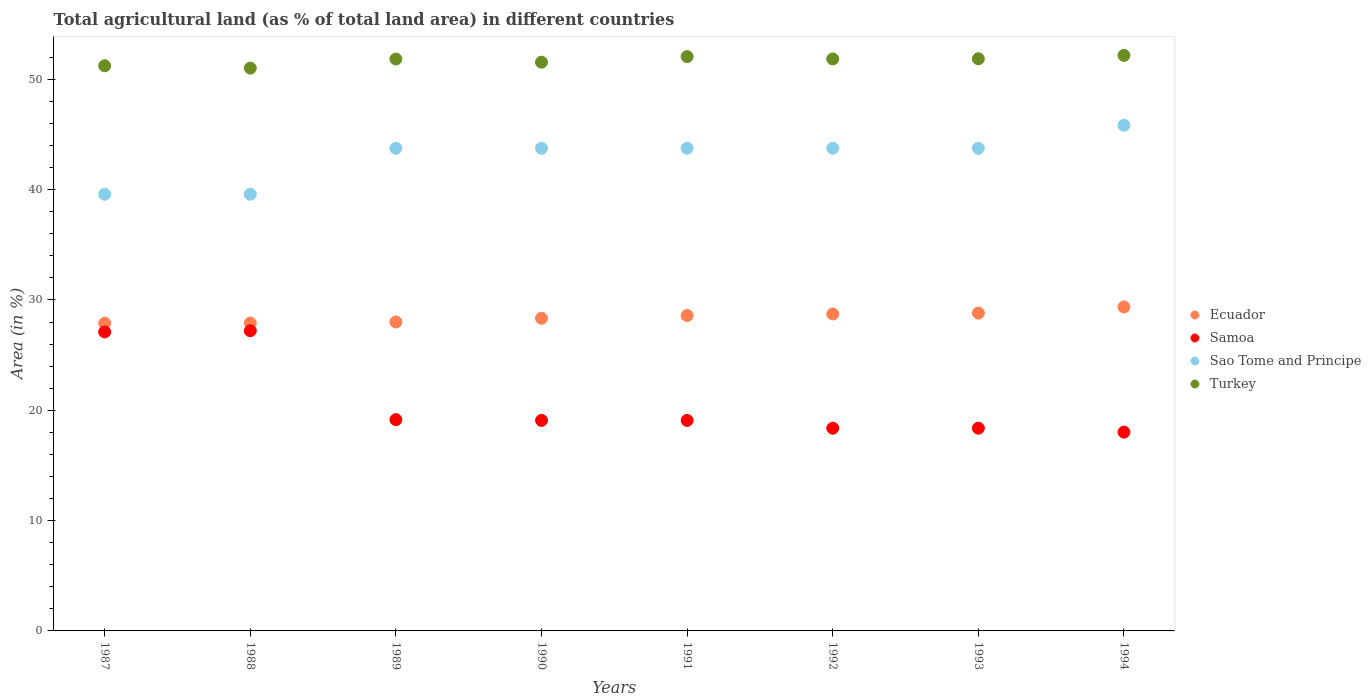Is the number of dotlines equal to the number of legend labels?
Keep it short and to the point. Yes. What is the percentage of agricultural land in Sao Tome and Principe in 1992?
Ensure brevity in your answer.  43.75. Across all years, what is the maximum percentage of agricultural land in Turkey?
Offer a terse response. 52.17. Across all years, what is the minimum percentage of agricultural land in Samoa?
Make the answer very short. 18.02. In which year was the percentage of agricultural land in Turkey minimum?
Your answer should be very brief. 1988. What is the total percentage of agricultural land in Sao Tome and Principe in the graph?
Your answer should be compact. 343.75. What is the difference between the percentage of agricultural land in Samoa in 1988 and that in 1994?
Provide a short and direct response. 9.19. What is the difference between the percentage of agricultural land in Samoa in 1993 and the percentage of agricultural land in Ecuador in 1992?
Provide a short and direct response. -10.35. What is the average percentage of agricultural land in Sao Tome and Principe per year?
Make the answer very short. 42.97. In the year 1990, what is the difference between the percentage of agricultural land in Samoa and percentage of agricultural land in Turkey?
Provide a succinct answer. -32.47. In how many years, is the percentage of agricultural land in Ecuador greater than 20 %?
Make the answer very short. 8. What is the ratio of the percentage of agricultural land in Ecuador in 1989 to that in 1991?
Give a very brief answer. 0.98. Is the percentage of agricultural land in Samoa in 1989 less than that in 1990?
Offer a very short reply. No. What is the difference between the highest and the second highest percentage of agricultural land in Samoa?
Ensure brevity in your answer.  0.11. What is the difference between the highest and the lowest percentage of agricultural land in Ecuador?
Make the answer very short. 1.47. In how many years, is the percentage of agricultural land in Ecuador greater than the average percentage of agricultural land in Ecuador taken over all years?
Your answer should be compact. 4. Is the sum of the percentage of agricultural land in Ecuador in 1989 and 1992 greater than the maximum percentage of agricultural land in Samoa across all years?
Your answer should be very brief. Yes. Is it the case that in every year, the sum of the percentage of agricultural land in Samoa and percentage of agricultural land in Turkey  is greater than the sum of percentage of agricultural land in Sao Tome and Principe and percentage of agricultural land in Ecuador?
Your response must be concise. No. Does the percentage of agricultural land in Samoa monotonically increase over the years?
Offer a very short reply. No. How many dotlines are there?
Provide a short and direct response. 4. Are the values on the major ticks of Y-axis written in scientific E-notation?
Provide a succinct answer. No. How many legend labels are there?
Your answer should be compact. 4. What is the title of the graph?
Provide a succinct answer. Total agricultural land (as % of total land area) in different countries. Does "Europe(all income levels)" appear as one of the legend labels in the graph?
Offer a terse response. No. What is the label or title of the Y-axis?
Offer a very short reply. Area (in %). What is the Area (in %) of Ecuador in 1987?
Give a very brief answer. 27.89. What is the Area (in %) in Samoa in 1987?
Your answer should be very brief. 27.1. What is the Area (in %) in Sao Tome and Principe in 1987?
Provide a short and direct response. 39.58. What is the Area (in %) in Turkey in 1987?
Your response must be concise. 51.23. What is the Area (in %) in Ecuador in 1988?
Make the answer very short. 27.91. What is the Area (in %) of Samoa in 1988?
Offer a terse response. 27.21. What is the Area (in %) of Sao Tome and Principe in 1988?
Keep it short and to the point. 39.58. What is the Area (in %) of Turkey in 1988?
Ensure brevity in your answer.  51.02. What is the Area (in %) in Ecuador in 1989?
Your answer should be very brief. 28.01. What is the Area (in %) in Samoa in 1989?
Give a very brief answer. 19.15. What is the Area (in %) of Sao Tome and Principe in 1989?
Offer a very short reply. 43.75. What is the Area (in %) of Turkey in 1989?
Give a very brief answer. 51.84. What is the Area (in %) in Ecuador in 1990?
Your answer should be very brief. 28.34. What is the Area (in %) of Samoa in 1990?
Give a very brief answer. 19.08. What is the Area (in %) in Sao Tome and Principe in 1990?
Provide a short and direct response. 43.75. What is the Area (in %) of Turkey in 1990?
Offer a very short reply. 51.55. What is the Area (in %) in Ecuador in 1991?
Offer a very short reply. 28.59. What is the Area (in %) of Samoa in 1991?
Offer a terse response. 19.08. What is the Area (in %) in Sao Tome and Principe in 1991?
Give a very brief answer. 43.75. What is the Area (in %) in Turkey in 1991?
Offer a very short reply. 52.06. What is the Area (in %) of Ecuador in 1992?
Provide a succinct answer. 28.73. What is the Area (in %) in Samoa in 1992?
Keep it short and to the point. 18.37. What is the Area (in %) of Sao Tome and Principe in 1992?
Offer a very short reply. 43.75. What is the Area (in %) of Turkey in 1992?
Give a very brief answer. 51.85. What is the Area (in %) of Ecuador in 1993?
Your answer should be compact. 28.81. What is the Area (in %) of Samoa in 1993?
Offer a very short reply. 18.37. What is the Area (in %) in Sao Tome and Principe in 1993?
Give a very brief answer. 43.75. What is the Area (in %) in Turkey in 1993?
Your answer should be very brief. 51.86. What is the Area (in %) in Ecuador in 1994?
Ensure brevity in your answer.  29.36. What is the Area (in %) in Samoa in 1994?
Your answer should be very brief. 18.02. What is the Area (in %) of Sao Tome and Principe in 1994?
Ensure brevity in your answer.  45.83. What is the Area (in %) of Turkey in 1994?
Offer a terse response. 52.17. Across all years, what is the maximum Area (in %) of Ecuador?
Give a very brief answer. 29.36. Across all years, what is the maximum Area (in %) of Samoa?
Your answer should be compact. 27.21. Across all years, what is the maximum Area (in %) of Sao Tome and Principe?
Offer a terse response. 45.83. Across all years, what is the maximum Area (in %) in Turkey?
Your response must be concise. 52.17. Across all years, what is the minimum Area (in %) of Ecuador?
Your answer should be very brief. 27.89. Across all years, what is the minimum Area (in %) in Samoa?
Make the answer very short. 18.02. Across all years, what is the minimum Area (in %) of Sao Tome and Principe?
Offer a terse response. 39.58. Across all years, what is the minimum Area (in %) of Turkey?
Offer a very short reply. 51.02. What is the total Area (in %) in Ecuador in the graph?
Make the answer very short. 227.63. What is the total Area (in %) in Samoa in the graph?
Give a very brief answer. 166.4. What is the total Area (in %) in Sao Tome and Principe in the graph?
Make the answer very short. 343.75. What is the total Area (in %) in Turkey in the graph?
Offer a terse response. 413.57. What is the difference between the Area (in %) in Ecuador in 1987 and that in 1988?
Keep it short and to the point. -0.02. What is the difference between the Area (in %) in Samoa in 1987 and that in 1988?
Offer a terse response. -0.11. What is the difference between the Area (in %) in Sao Tome and Principe in 1987 and that in 1988?
Offer a very short reply. 0. What is the difference between the Area (in %) of Turkey in 1987 and that in 1988?
Provide a succinct answer. 0.21. What is the difference between the Area (in %) in Ecuador in 1987 and that in 1989?
Your answer should be very brief. -0.12. What is the difference between the Area (in %) in Samoa in 1987 and that in 1989?
Give a very brief answer. 7.95. What is the difference between the Area (in %) of Sao Tome and Principe in 1987 and that in 1989?
Provide a short and direct response. -4.17. What is the difference between the Area (in %) of Turkey in 1987 and that in 1989?
Your answer should be very brief. -0.61. What is the difference between the Area (in %) in Ecuador in 1987 and that in 1990?
Offer a terse response. -0.45. What is the difference between the Area (in %) in Samoa in 1987 and that in 1990?
Make the answer very short. 8.02. What is the difference between the Area (in %) in Sao Tome and Principe in 1987 and that in 1990?
Offer a very short reply. -4.17. What is the difference between the Area (in %) in Turkey in 1987 and that in 1990?
Your answer should be compact. -0.32. What is the difference between the Area (in %) in Ecuador in 1987 and that in 1991?
Provide a short and direct response. -0.7. What is the difference between the Area (in %) in Samoa in 1987 and that in 1991?
Offer a terse response. 8.02. What is the difference between the Area (in %) in Sao Tome and Principe in 1987 and that in 1991?
Give a very brief answer. -4.17. What is the difference between the Area (in %) in Turkey in 1987 and that in 1991?
Offer a terse response. -0.83. What is the difference between the Area (in %) of Ecuador in 1987 and that in 1992?
Provide a short and direct response. -0.84. What is the difference between the Area (in %) in Samoa in 1987 and that in 1992?
Keep it short and to the point. 8.73. What is the difference between the Area (in %) in Sao Tome and Principe in 1987 and that in 1992?
Provide a succinct answer. -4.17. What is the difference between the Area (in %) in Turkey in 1987 and that in 1992?
Your response must be concise. -0.62. What is the difference between the Area (in %) of Ecuador in 1987 and that in 1993?
Make the answer very short. -0.92. What is the difference between the Area (in %) of Samoa in 1987 and that in 1993?
Give a very brief answer. 8.73. What is the difference between the Area (in %) of Sao Tome and Principe in 1987 and that in 1993?
Ensure brevity in your answer.  -4.17. What is the difference between the Area (in %) in Turkey in 1987 and that in 1993?
Provide a succinct answer. -0.63. What is the difference between the Area (in %) of Ecuador in 1987 and that in 1994?
Give a very brief answer. -1.47. What is the difference between the Area (in %) in Samoa in 1987 and that in 1994?
Offer a terse response. 9.08. What is the difference between the Area (in %) of Sao Tome and Principe in 1987 and that in 1994?
Keep it short and to the point. -6.25. What is the difference between the Area (in %) of Turkey in 1987 and that in 1994?
Provide a succinct answer. -0.94. What is the difference between the Area (in %) in Ecuador in 1988 and that in 1989?
Ensure brevity in your answer.  -0.1. What is the difference between the Area (in %) of Samoa in 1988 and that in 1989?
Provide a short and direct response. 8.06. What is the difference between the Area (in %) in Sao Tome and Principe in 1988 and that in 1989?
Make the answer very short. -4.17. What is the difference between the Area (in %) in Turkey in 1988 and that in 1989?
Your answer should be compact. -0.82. What is the difference between the Area (in %) in Ecuador in 1988 and that in 1990?
Your answer should be very brief. -0.43. What is the difference between the Area (in %) in Samoa in 1988 and that in 1990?
Your response must be concise. 8.13. What is the difference between the Area (in %) in Sao Tome and Principe in 1988 and that in 1990?
Ensure brevity in your answer.  -4.17. What is the difference between the Area (in %) in Turkey in 1988 and that in 1990?
Give a very brief answer. -0.54. What is the difference between the Area (in %) of Ecuador in 1988 and that in 1991?
Give a very brief answer. -0.68. What is the difference between the Area (in %) in Samoa in 1988 and that in 1991?
Keep it short and to the point. 8.13. What is the difference between the Area (in %) in Sao Tome and Principe in 1988 and that in 1991?
Offer a terse response. -4.17. What is the difference between the Area (in %) in Turkey in 1988 and that in 1991?
Provide a succinct answer. -1.04. What is the difference between the Area (in %) of Ecuador in 1988 and that in 1992?
Your answer should be compact. -0.82. What is the difference between the Area (in %) of Samoa in 1988 and that in 1992?
Give a very brief answer. 8.83. What is the difference between the Area (in %) of Sao Tome and Principe in 1988 and that in 1992?
Provide a short and direct response. -4.17. What is the difference between the Area (in %) of Turkey in 1988 and that in 1992?
Your answer should be compact. -0.83. What is the difference between the Area (in %) in Ecuador in 1988 and that in 1993?
Keep it short and to the point. -0.9. What is the difference between the Area (in %) in Samoa in 1988 and that in 1993?
Ensure brevity in your answer.  8.83. What is the difference between the Area (in %) in Sao Tome and Principe in 1988 and that in 1993?
Your response must be concise. -4.17. What is the difference between the Area (in %) in Turkey in 1988 and that in 1993?
Provide a succinct answer. -0.84. What is the difference between the Area (in %) of Ecuador in 1988 and that in 1994?
Provide a short and direct response. -1.46. What is the difference between the Area (in %) in Samoa in 1988 and that in 1994?
Ensure brevity in your answer.  9.19. What is the difference between the Area (in %) of Sao Tome and Principe in 1988 and that in 1994?
Ensure brevity in your answer.  -6.25. What is the difference between the Area (in %) in Turkey in 1988 and that in 1994?
Your response must be concise. -1.15. What is the difference between the Area (in %) in Ecuador in 1989 and that in 1990?
Offer a terse response. -0.34. What is the difference between the Area (in %) in Samoa in 1989 and that in 1990?
Give a very brief answer. 0.07. What is the difference between the Area (in %) of Sao Tome and Principe in 1989 and that in 1990?
Offer a very short reply. 0. What is the difference between the Area (in %) of Turkey in 1989 and that in 1990?
Your response must be concise. 0.29. What is the difference between the Area (in %) of Ecuador in 1989 and that in 1991?
Provide a short and direct response. -0.58. What is the difference between the Area (in %) in Samoa in 1989 and that in 1991?
Your answer should be compact. 0.07. What is the difference between the Area (in %) of Sao Tome and Principe in 1989 and that in 1991?
Your answer should be compact. 0. What is the difference between the Area (in %) in Turkey in 1989 and that in 1991?
Provide a succinct answer. -0.22. What is the difference between the Area (in %) in Ecuador in 1989 and that in 1992?
Make the answer very short. -0.72. What is the difference between the Area (in %) in Samoa in 1989 and that in 1992?
Offer a terse response. 0.78. What is the difference between the Area (in %) of Sao Tome and Principe in 1989 and that in 1992?
Provide a short and direct response. 0. What is the difference between the Area (in %) in Turkey in 1989 and that in 1992?
Your response must be concise. -0.01. What is the difference between the Area (in %) of Ecuador in 1989 and that in 1993?
Your response must be concise. -0.8. What is the difference between the Area (in %) of Samoa in 1989 and that in 1993?
Make the answer very short. 0.78. What is the difference between the Area (in %) of Turkey in 1989 and that in 1993?
Your response must be concise. -0.02. What is the difference between the Area (in %) of Ecuador in 1989 and that in 1994?
Give a very brief answer. -1.36. What is the difference between the Area (in %) of Samoa in 1989 and that in 1994?
Your response must be concise. 1.13. What is the difference between the Area (in %) of Sao Tome and Principe in 1989 and that in 1994?
Make the answer very short. -2.08. What is the difference between the Area (in %) of Turkey in 1989 and that in 1994?
Keep it short and to the point. -0.33. What is the difference between the Area (in %) in Ecuador in 1990 and that in 1991?
Give a very brief answer. -0.25. What is the difference between the Area (in %) of Samoa in 1990 and that in 1991?
Provide a succinct answer. 0. What is the difference between the Area (in %) of Sao Tome and Principe in 1990 and that in 1991?
Offer a very short reply. 0. What is the difference between the Area (in %) of Turkey in 1990 and that in 1991?
Offer a terse response. -0.51. What is the difference between the Area (in %) in Ecuador in 1990 and that in 1992?
Provide a short and direct response. -0.39. What is the difference between the Area (in %) of Samoa in 1990 and that in 1992?
Provide a short and direct response. 0.71. What is the difference between the Area (in %) in Turkey in 1990 and that in 1992?
Give a very brief answer. -0.29. What is the difference between the Area (in %) in Ecuador in 1990 and that in 1993?
Your response must be concise. -0.47. What is the difference between the Area (in %) in Samoa in 1990 and that in 1993?
Keep it short and to the point. 0.71. What is the difference between the Area (in %) in Sao Tome and Principe in 1990 and that in 1993?
Your answer should be very brief. 0. What is the difference between the Area (in %) of Turkey in 1990 and that in 1993?
Provide a short and direct response. -0.31. What is the difference between the Area (in %) of Ecuador in 1990 and that in 1994?
Offer a terse response. -1.02. What is the difference between the Area (in %) in Samoa in 1990 and that in 1994?
Your response must be concise. 1.06. What is the difference between the Area (in %) of Sao Tome and Principe in 1990 and that in 1994?
Offer a very short reply. -2.08. What is the difference between the Area (in %) of Turkey in 1990 and that in 1994?
Give a very brief answer. -0.61. What is the difference between the Area (in %) of Ecuador in 1991 and that in 1992?
Your answer should be compact. -0.14. What is the difference between the Area (in %) of Samoa in 1991 and that in 1992?
Offer a very short reply. 0.71. What is the difference between the Area (in %) of Sao Tome and Principe in 1991 and that in 1992?
Provide a short and direct response. 0. What is the difference between the Area (in %) in Turkey in 1991 and that in 1992?
Your response must be concise. 0.21. What is the difference between the Area (in %) of Ecuador in 1991 and that in 1993?
Make the answer very short. -0.22. What is the difference between the Area (in %) of Samoa in 1991 and that in 1993?
Provide a succinct answer. 0.71. What is the difference between the Area (in %) in Turkey in 1991 and that in 1993?
Ensure brevity in your answer.  0.2. What is the difference between the Area (in %) in Ecuador in 1991 and that in 1994?
Ensure brevity in your answer.  -0.78. What is the difference between the Area (in %) in Samoa in 1991 and that in 1994?
Your answer should be compact. 1.06. What is the difference between the Area (in %) of Sao Tome and Principe in 1991 and that in 1994?
Ensure brevity in your answer.  -2.08. What is the difference between the Area (in %) of Turkey in 1991 and that in 1994?
Provide a succinct answer. -0.11. What is the difference between the Area (in %) of Ecuador in 1992 and that in 1993?
Keep it short and to the point. -0.08. What is the difference between the Area (in %) in Sao Tome and Principe in 1992 and that in 1993?
Give a very brief answer. 0. What is the difference between the Area (in %) in Turkey in 1992 and that in 1993?
Your answer should be very brief. -0.01. What is the difference between the Area (in %) in Ecuador in 1992 and that in 1994?
Provide a succinct answer. -0.64. What is the difference between the Area (in %) of Samoa in 1992 and that in 1994?
Your answer should be very brief. 0.35. What is the difference between the Area (in %) of Sao Tome and Principe in 1992 and that in 1994?
Offer a terse response. -2.08. What is the difference between the Area (in %) of Turkey in 1992 and that in 1994?
Ensure brevity in your answer.  -0.32. What is the difference between the Area (in %) in Ecuador in 1993 and that in 1994?
Ensure brevity in your answer.  -0.56. What is the difference between the Area (in %) in Samoa in 1993 and that in 1994?
Give a very brief answer. 0.35. What is the difference between the Area (in %) in Sao Tome and Principe in 1993 and that in 1994?
Offer a terse response. -2.08. What is the difference between the Area (in %) of Turkey in 1993 and that in 1994?
Offer a terse response. -0.31. What is the difference between the Area (in %) of Ecuador in 1987 and the Area (in %) of Samoa in 1988?
Keep it short and to the point. 0.68. What is the difference between the Area (in %) of Ecuador in 1987 and the Area (in %) of Sao Tome and Principe in 1988?
Your answer should be compact. -11.69. What is the difference between the Area (in %) of Ecuador in 1987 and the Area (in %) of Turkey in 1988?
Offer a terse response. -23.13. What is the difference between the Area (in %) in Samoa in 1987 and the Area (in %) in Sao Tome and Principe in 1988?
Your answer should be very brief. -12.48. What is the difference between the Area (in %) of Samoa in 1987 and the Area (in %) of Turkey in 1988?
Offer a terse response. -23.91. What is the difference between the Area (in %) in Sao Tome and Principe in 1987 and the Area (in %) in Turkey in 1988?
Your answer should be very brief. -11.43. What is the difference between the Area (in %) in Ecuador in 1987 and the Area (in %) in Samoa in 1989?
Provide a succinct answer. 8.74. What is the difference between the Area (in %) of Ecuador in 1987 and the Area (in %) of Sao Tome and Principe in 1989?
Keep it short and to the point. -15.86. What is the difference between the Area (in %) of Ecuador in 1987 and the Area (in %) of Turkey in 1989?
Provide a short and direct response. -23.95. What is the difference between the Area (in %) of Samoa in 1987 and the Area (in %) of Sao Tome and Principe in 1989?
Ensure brevity in your answer.  -16.65. What is the difference between the Area (in %) in Samoa in 1987 and the Area (in %) in Turkey in 1989?
Your response must be concise. -24.74. What is the difference between the Area (in %) of Sao Tome and Principe in 1987 and the Area (in %) of Turkey in 1989?
Ensure brevity in your answer.  -12.26. What is the difference between the Area (in %) of Ecuador in 1987 and the Area (in %) of Samoa in 1990?
Keep it short and to the point. 8.81. What is the difference between the Area (in %) of Ecuador in 1987 and the Area (in %) of Sao Tome and Principe in 1990?
Your answer should be compact. -15.86. What is the difference between the Area (in %) in Ecuador in 1987 and the Area (in %) in Turkey in 1990?
Ensure brevity in your answer.  -23.66. What is the difference between the Area (in %) in Samoa in 1987 and the Area (in %) in Sao Tome and Principe in 1990?
Offer a very short reply. -16.65. What is the difference between the Area (in %) of Samoa in 1987 and the Area (in %) of Turkey in 1990?
Your answer should be compact. -24.45. What is the difference between the Area (in %) in Sao Tome and Principe in 1987 and the Area (in %) in Turkey in 1990?
Ensure brevity in your answer.  -11.97. What is the difference between the Area (in %) in Ecuador in 1987 and the Area (in %) in Samoa in 1991?
Offer a terse response. 8.81. What is the difference between the Area (in %) of Ecuador in 1987 and the Area (in %) of Sao Tome and Principe in 1991?
Your answer should be very brief. -15.86. What is the difference between the Area (in %) in Ecuador in 1987 and the Area (in %) in Turkey in 1991?
Give a very brief answer. -24.17. What is the difference between the Area (in %) in Samoa in 1987 and the Area (in %) in Sao Tome and Principe in 1991?
Keep it short and to the point. -16.65. What is the difference between the Area (in %) in Samoa in 1987 and the Area (in %) in Turkey in 1991?
Provide a succinct answer. -24.96. What is the difference between the Area (in %) in Sao Tome and Principe in 1987 and the Area (in %) in Turkey in 1991?
Your response must be concise. -12.48. What is the difference between the Area (in %) of Ecuador in 1987 and the Area (in %) of Samoa in 1992?
Provide a short and direct response. 9.52. What is the difference between the Area (in %) in Ecuador in 1987 and the Area (in %) in Sao Tome and Principe in 1992?
Provide a succinct answer. -15.86. What is the difference between the Area (in %) in Ecuador in 1987 and the Area (in %) in Turkey in 1992?
Give a very brief answer. -23.96. What is the difference between the Area (in %) of Samoa in 1987 and the Area (in %) of Sao Tome and Principe in 1992?
Make the answer very short. -16.65. What is the difference between the Area (in %) in Samoa in 1987 and the Area (in %) in Turkey in 1992?
Give a very brief answer. -24.75. What is the difference between the Area (in %) of Sao Tome and Principe in 1987 and the Area (in %) of Turkey in 1992?
Make the answer very short. -12.27. What is the difference between the Area (in %) of Ecuador in 1987 and the Area (in %) of Samoa in 1993?
Offer a very short reply. 9.52. What is the difference between the Area (in %) of Ecuador in 1987 and the Area (in %) of Sao Tome and Principe in 1993?
Ensure brevity in your answer.  -15.86. What is the difference between the Area (in %) of Ecuador in 1987 and the Area (in %) of Turkey in 1993?
Ensure brevity in your answer.  -23.97. What is the difference between the Area (in %) of Samoa in 1987 and the Area (in %) of Sao Tome and Principe in 1993?
Give a very brief answer. -16.65. What is the difference between the Area (in %) of Samoa in 1987 and the Area (in %) of Turkey in 1993?
Keep it short and to the point. -24.76. What is the difference between the Area (in %) in Sao Tome and Principe in 1987 and the Area (in %) in Turkey in 1993?
Ensure brevity in your answer.  -12.28. What is the difference between the Area (in %) in Ecuador in 1987 and the Area (in %) in Samoa in 1994?
Your answer should be very brief. 9.87. What is the difference between the Area (in %) of Ecuador in 1987 and the Area (in %) of Sao Tome and Principe in 1994?
Make the answer very short. -17.94. What is the difference between the Area (in %) of Ecuador in 1987 and the Area (in %) of Turkey in 1994?
Your response must be concise. -24.28. What is the difference between the Area (in %) in Samoa in 1987 and the Area (in %) in Sao Tome and Principe in 1994?
Offer a very short reply. -18.73. What is the difference between the Area (in %) of Samoa in 1987 and the Area (in %) of Turkey in 1994?
Make the answer very short. -25.06. What is the difference between the Area (in %) in Sao Tome and Principe in 1987 and the Area (in %) in Turkey in 1994?
Provide a succinct answer. -12.58. What is the difference between the Area (in %) of Ecuador in 1988 and the Area (in %) of Samoa in 1989?
Provide a short and direct response. 8.76. What is the difference between the Area (in %) of Ecuador in 1988 and the Area (in %) of Sao Tome and Principe in 1989?
Ensure brevity in your answer.  -15.84. What is the difference between the Area (in %) in Ecuador in 1988 and the Area (in %) in Turkey in 1989?
Give a very brief answer. -23.93. What is the difference between the Area (in %) in Samoa in 1988 and the Area (in %) in Sao Tome and Principe in 1989?
Your response must be concise. -16.54. What is the difference between the Area (in %) in Samoa in 1988 and the Area (in %) in Turkey in 1989?
Your answer should be compact. -24.63. What is the difference between the Area (in %) in Sao Tome and Principe in 1988 and the Area (in %) in Turkey in 1989?
Provide a short and direct response. -12.26. What is the difference between the Area (in %) of Ecuador in 1988 and the Area (in %) of Samoa in 1990?
Offer a terse response. 8.83. What is the difference between the Area (in %) in Ecuador in 1988 and the Area (in %) in Sao Tome and Principe in 1990?
Your answer should be very brief. -15.84. What is the difference between the Area (in %) in Ecuador in 1988 and the Area (in %) in Turkey in 1990?
Make the answer very short. -23.65. What is the difference between the Area (in %) of Samoa in 1988 and the Area (in %) of Sao Tome and Principe in 1990?
Keep it short and to the point. -16.54. What is the difference between the Area (in %) in Samoa in 1988 and the Area (in %) in Turkey in 1990?
Provide a short and direct response. -24.34. What is the difference between the Area (in %) of Sao Tome and Principe in 1988 and the Area (in %) of Turkey in 1990?
Keep it short and to the point. -11.97. What is the difference between the Area (in %) of Ecuador in 1988 and the Area (in %) of Samoa in 1991?
Offer a very short reply. 8.83. What is the difference between the Area (in %) in Ecuador in 1988 and the Area (in %) in Sao Tome and Principe in 1991?
Provide a short and direct response. -15.84. What is the difference between the Area (in %) in Ecuador in 1988 and the Area (in %) in Turkey in 1991?
Offer a terse response. -24.15. What is the difference between the Area (in %) of Samoa in 1988 and the Area (in %) of Sao Tome and Principe in 1991?
Your response must be concise. -16.54. What is the difference between the Area (in %) in Samoa in 1988 and the Area (in %) in Turkey in 1991?
Your response must be concise. -24.85. What is the difference between the Area (in %) of Sao Tome and Principe in 1988 and the Area (in %) of Turkey in 1991?
Your answer should be very brief. -12.48. What is the difference between the Area (in %) of Ecuador in 1988 and the Area (in %) of Samoa in 1992?
Offer a very short reply. 9.53. What is the difference between the Area (in %) in Ecuador in 1988 and the Area (in %) in Sao Tome and Principe in 1992?
Provide a short and direct response. -15.84. What is the difference between the Area (in %) of Ecuador in 1988 and the Area (in %) of Turkey in 1992?
Give a very brief answer. -23.94. What is the difference between the Area (in %) of Samoa in 1988 and the Area (in %) of Sao Tome and Principe in 1992?
Offer a terse response. -16.54. What is the difference between the Area (in %) of Samoa in 1988 and the Area (in %) of Turkey in 1992?
Keep it short and to the point. -24.64. What is the difference between the Area (in %) in Sao Tome and Principe in 1988 and the Area (in %) in Turkey in 1992?
Your response must be concise. -12.27. What is the difference between the Area (in %) in Ecuador in 1988 and the Area (in %) in Samoa in 1993?
Make the answer very short. 9.53. What is the difference between the Area (in %) in Ecuador in 1988 and the Area (in %) in Sao Tome and Principe in 1993?
Give a very brief answer. -15.84. What is the difference between the Area (in %) in Ecuador in 1988 and the Area (in %) in Turkey in 1993?
Offer a very short reply. -23.95. What is the difference between the Area (in %) of Samoa in 1988 and the Area (in %) of Sao Tome and Principe in 1993?
Provide a short and direct response. -16.54. What is the difference between the Area (in %) in Samoa in 1988 and the Area (in %) in Turkey in 1993?
Provide a short and direct response. -24.65. What is the difference between the Area (in %) of Sao Tome and Principe in 1988 and the Area (in %) of Turkey in 1993?
Offer a very short reply. -12.28. What is the difference between the Area (in %) in Ecuador in 1988 and the Area (in %) in Samoa in 1994?
Your answer should be compact. 9.89. What is the difference between the Area (in %) of Ecuador in 1988 and the Area (in %) of Sao Tome and Principe in 1994?
Your answer should be very brief. -17.93. What is the difference between the Area (in %) in Ecuador in 1988 and the Area (in %) in Turkey in 1994?
Offer a very short reply. -24.26. What is the difference between the Area (in %) of Samoa in 1988 and the Area (in %) of Sao Tome and Principe in 1994?
Offer a very short reply. -18.62. What is the difference between the Area (in %) of Samoa in 1988 and the Area (in %) of Turkey in 1994?
Your answer should be very brief. -24.96. What is the difference between the Area (in %) in Sao Tome and Principe in 1988 and the Area (in %) in Turkey in 1994?
Offer a terse response. -12.58. What is the difference between the Area (in %) of Ecuador in 1989 and the Area (in %) of Samoa in 1990?
Ensure brevity in your answer.  8.92. What is the difference between the Area (in %) in Ecuador in 1989 and the Area (in %) in Sao Tome and Principe in 1990?
Your answer should be very brief. -15.74. What is the difference between the Area (in %) of Ecuador in 1989 and the Area (in %) of Turkey in 1990?
Your answer should be compact. -23.55. What is the difference between the Area (in %) in Samoa in 1989 and the Area (in %) in Sao Tome and Principe in 1990?
Your answer should be very brief. -24.6. What is the difference between the Area (in %) in Samoa in 1989 and the Area (in %) in Turkey in 1990?
Provide a succinct answer. -32.4. What is the difference between the Area (in %) of Sao Tome and Principe in 1989 and the Area (in %) of Turkey in 1990?
Keep it short and to the point. -7.8. What is the difference between the Area (in %) in Ecuador in 1989 and the Area (in %) in Samoa in 1991?
Keep it short and to the point. 8.92. What is the difference between the Area (in %) in Ecuador in 1989 and the Area (in %) in Sao Tome and Principe in 1991?
Keep it short and to the point. -15.74. What is the difference between the Area (in %) of Ecuador in 1989 and the Area (in %) of Turkey in 1991?
Your response must be concise. -24.05. What is the difference between the Area (in %) in Samoa in 1989 and the Area (in %) in Sao Tome and Principe in 1991?
Your answer should be compact. -24.6. What is the difference between the Area (in %) in Samoa in 1989 and the Area (in %) in Turkey in 1991?
Ensure brevity in your answer.  -32.91. What is the difference between the Area (in %) in Sao Tome and Principe in 1989 and the Area (in %) in Turkey in 1991?
Make the answer very short. -8.31. What is the difference between the Area (in %) in Ecuador in 1989 and the Area (in %) in Samoa in 1992?
Offer a very short reply. 9.63. What is the difference between the Area (in %) of Ecuador in 1989 and the Area (in %) of Sao Tome and Principe in 1992?
Provide a succinct answer. -15.74. What is the difference between the Area (in %) in Ecuador in 1989 and the Area (in %) in Turkey in 1992?
Make the answer very short. -23.84. What is the difference between the Area (in %) of Samoa in 1989 and the Area (in %) of Sao Tome and Principe in 1992?
Make the answer very short. -24.6. What is the difference between the Area (in %) in Samoa in 1989 and the Area (in %) in Turkey in 1992?
Provide a succinct answer. -32.7. What is the difference between the Area (in %) in Sao Tome and Principe in 1989 and the Area (in %) in Turkey in 1992?
Offer a very short reply. -8.1. What is the difference between the Area (in %) in Ecuador in 1989 and the Area (in %) in Samoa in 1993?
Provide a short and direct response. 9.63. What is the difference between the Area (in %) of Ecuador in 1989 and the Area (in %) of Sao Tome and Principe in 1993?
Your response must be concise. -15.74. What is the difference between the Area (in %) of Ecuador in 1989 and the Area (in %) of Turkey in 1993?
Ensure brevity in your answer.  -23.85. What is the difference between the Area (in %) of Samoa in 1989 and the Area (in %) of Sao Tome and Principe in 1993?
Make the answer very short. -24.6. What is the difference between the Area (in %) in Samoa in 1989 and the Area (in %) in Turkey in 1993?
Ensure brevity in your answer.  -32.71. What is the difference between the Area (in %) in Sao Tome and Principe in 1989 and the Area (in %) in Turkey in 1993?
Your response must be concise. -8.11. What is the difference between the Area (in %) in Ecuador in 1989 and the Area (in %) in Samoa in 1994?
Provide a succinct answer. 9.98. What is the difference between the Area (in %) of Ecuador in 1989 and the Area (in %) of Sao Tome and Principe in 1994?
Provide a short and direct response. -17.83. What is the difference between the Area (in %) of Ecuador in 1989 and the Area (in %) of Turkey in 1994?
Provide a succinct answer. -24.16. What is the difference between the Area (in %) of Samoa in 1989 and the Area (in %) of Sao Tome and Principe in 1994?
Provide a succinct answer. -26.68. What is the difference between the Area (in %) of Samoa in 1989 and the Area (in %) of Turkey in 1994?
Give a very brief answer. -33.01. What is the difference between the Area (in %) of Sao Tome and Principe in 1989 and the Area (in %) of Turkey in 1994?
Ensure brevity in your answer.  -8.42. What is the difference between the Area (in %) in Ecuador in 1990 and the Area (in %) in Samoa in 1991?
Provide a short and direct response. 9.26. What is the difference between the Area (in %) of Ecuador in 1990 and the Area (in %) of Sao Tome and Principe in 1991?
Your answer should be very brief. -15.41. What is the difference between the Area (in %) of Ecuador in 1990 and the Area (in %) of Turkey in 1991?
Give a very brief answer. -23.72. What is the difference between the Area (in %) of Samoa in 1990 and the Area (in %) of Sao Tome and Principe in 1991?
Your response must be concise. -24.67. What is the difference between the Area (in %) in Samoa in 1990 and the Area (in %) in Turkey in 1991?
Give a very brief answer. -32.98. What is the difference between the Area (in %) in Sao Tome and Principe in 1990 and the Area (in %) in Turkey in 1991?
Ensure brevity in your answer.  -8.31. What is the difference between the Area (in %) of Ecuador in 1990 and the Area (in %) of Samoa in 1992?
Your answer should be compact. 9.97. What is the difference between the Area (in %) of Ecuador in 1990 and the Area (in %) of Sao Tome and Principe in 1992?
Ensure brevity in your answer.  -15.41. What is the difference between the Area (in %) in Ecuador in 1990 and the Area (in %) in Turkey in 1992?
Provide a short and direct response. -23.51. What is the difference between the Area (in %) of Samoa in 1990 and the Area (in %) of Sao Tome and Principe in 1992?
Offer a terse response. -24.67. What is the difference between the Area (in %) of Samoa in 1990 and the Area (in %) of Turkey in 1992?
Make the answer very short. -32.77. What is the difference between the Area (in %) in Sao Tome and Principe in 1990 and the Area (in %) in Turkey in 1992?
Ensure brevity in your answer.  -8.1. What is the difference between the Area (in %) in Ecuador in 1990 and the Area (in %) in Samoa in 1993?
Offer a terse response. 9.97. What is the difference between the Area (in %) of Ecuador in 1990 and the Area (in %) of Sao Tome and Principe in 1993?
Your answer should be very brief. -15.41. What is the difference between the Area (in %) of Ecuador in 1990 and the Area (in %) of Turkey in 1993?
Keep it short and to the point. -23.52. What is the difference between the Area (in %) in Samoa in 1990 and the Area (in %) in Sao Tome and Principe in 1993?
Ensure brevity in your answer.  -24.67. What is the difference between the Area (in %) of Samoa in 1990 and the Area (in %) of Turkey in 1993?
Make the answer very short. -32.78. What is the difference between the Area (in %) of Sao Tome and Principe in 1990 and the Area (in %) of Turkey in 1993?
Your answer should be very brief. -8.11. What is the difference between the Area (in %) in Ecuador in 1990 and the Area (in %) in Samoa in 1994?
Offer a terse response. 10.32. What is the difference between the Area (in %) of Ecuador in 1990 and the Area (in %) of Sao Tome and Principe in 1994?
Provide a succinct answer. -17.49. What is the difference between the Area (in %) of Ecuador in 1990 and the Area (in %) of Turkey in 1994?
Your response must be concise. -23.83. What is the difference between the Area (in %) in Samoa in 1990 and the Area (in %) in Sao Tome and Principe in 1994?
Offer a terse response. -26.75. What is the difference between the Area (in %) of Samoa in 1990 and the Area (in %) of Turkey in 1994?
Offer a terse response. -33.09. What is the difference between the Area (in %) in Sao Tome and Principe in 1990 and the Area (in %) in Turkey in 1994?
Your answer should be compact. -8.42. What is the difference between the Area (in %) in Ecuador in 1991 and the Area (in %) in Samoa in 1992?
Your response must be concise. 10.21. What is the difference between the Area (in %) in Ecuador in 1991 and the Area (in %) in Sao Tome and Principe in 1992?
Your response must be concise. -15.16. What is the difference between the Area (in %) in Ecuador in 1991 and the Area (in %) in Turkey in 1992?
Ensure brevity in your answer.  -23.26. What is the difference between the Area (in %) of Samoa in 1991 and the Area (in %) of Sao Tome and Principe in 1992?
Your answer should be compact. -24.67. What is the difference between the Area (in %) of Samoa in 1991 and the Area (in %) of Turkey in 1992?
Your response must be concise. -32.77. What is the difference between the Area (in %) of Sao Tome and Principe in 1991 and the Area (in %) of Turkey in 1992?
Your answer should be very brief. -8.1. What is the difference between the Area (in %) in Ecuador in 1991 and the Area (in %) in Samoa in 1993?
Make the answer very short. 10.21. What is the difference between the Area (in %) in Ecuador in 1991 and the Area (in %) in Sao Tome and Principe in 1993?
Ensure brevity in your answer.  -15.16. What is the difference between the Area (in %) in Ecuador in 1991 and the Area (in %) in Turkey in 1993?
Make the answer very short. -23.27. What is the difference between the Area (in %) in Samoa in 1991 and the Area (in %) in Sao Tome and Principe in 1993?
Your answer should be compact. -24.67. What is the difference between the Area (in %) in Samoa in 1991 and the Area (in %) in Turkey in 1993?
Keep it short and to the point. -32.78. What is the difference between the Area (in %) in Sao Tome and Principe in 1991 and the Area (in %) in Turkey in 1993?
Your answer should be very brief. -8.11. What is the difference between the Area (in %) of Ecuador in 1991 and the Area (in %) of Samoa in 1994?
Provide a succinct answer. 10.57. What is the difference between the Area (in %) of Ecuador in 1991 and the Area (in %) of Sao Tome and Principe in 1994?
Your response must be concise. -17.25. What is the difference between the Area (in %) in Ecuador in 1991 and the Area (in %) in Turkey in 1994?
Make the answer very short. -23.58. What is the difference between the Area (in %) of Samoa in 1991 and the Area (in %) of Sao Tome and Principe in 1994?
Your response must be concise. -26.75. What is the difference between the Area (in %) of Samoa in 1991 and the Area (in %) of Turkey in 1994?
Offer a very short reply. -33.09. What is the difference between the Area (in %) in Sao Tome and Principe in 1991 and the Area (in %) in Turkey in 1994?
Give a very brief answer. -8.42. What is the difference between the Area (in %) in Ecuador in 1992 and the Area (in %) in Samoa in 1993?
Your answer should be compact. 10.35. What is the difference between the Area (in %) of Ecuador in 1992 and the Area (in %) of Sao Tome and Principe in 1993?
Keep it short and to the point. -15.02. What is the difference between the Area (in %) of Ecuador in 1992 and the Area (in %) of Turkey in 1993?
Make the answer very short. -23.13. What is the difference between the Area (in %) of Samoa in 1992 and the Area (in %) of Sao Tome and Principe in 1993?
Your response must be concise. -25.38. What is the difference between the Area (in %) in Samoa in 1992 and the Area (in %) in Turkey in 1993?
Provide a short and direct response. -33.49. What is the difference between the Area (in %) of Sao Tome and Principe in 1992 and the Area (in %) of Turkey in 1993?
Keep it short and to the point. -8.11. What is the difference between the Area (in %) of Ecuador in 1992 and the Area (in %) of Samoa in 1994?
Give a very brief answer. 10.71. What is the difference between the Area (in %) of Ecuador in 1992 and the Area (in %) of Sao Tome and Principe in 1994?
Offer a terse response. -17.11. What is the difference between the Area (in %) of Ecuador in 1992 and the Area (in %) of Turkey in 1994?
Your answer should be very brief. -23.44. What is the difference between the Area (in %) in Samoa in 1992 and the Area (in %) in Sao Tome and Principe in 1994?
Offer a very short reply. -27.46. What is the difference between the Area (in %) in Samoa in 1992 and the Area (in %) in Turkey in 1994?
Provide a short and direct response. -33.79. What is the difference between the Area (in %) of Sao Tome and Principe in 1992 and the Area (in %) of Turkey in 1994?
Make the answer very short. -8.42. What is the difference between the Area (in %) in Ecuador in 1993 and the Area (in %) in Samoa in 1994?
Give a very brief answer. 10.79. What is the difference between the Area (in %) in Ecuador in 1993 and the Area (in %) in Sao Tome and Principe in 1994?
Ensure brevity in your answer.  -17.03. What is the difference between the Area (in %) in Ecuador in 1993 and the Area (in %) in Turkey in 1994?
Give a very brief answer. -23.36. What is the difference between the Area (in %) of Samoa in 1993 and the Area (in %) of Sao Tome and Principe in 1994?
Keep it short and to the point. -27.46. What is the difference between the Area (in %) of Samoa in 1993 and the Area (in %) of Turkey in 1994?
Provide a succinct answer. -33.79. What is the difference between the Area (in %) of Sao Tome and Principe in 1993 and the Area (in %) of Turkey in 1994?
Offer a very short reply. -8.42. What is the average Area (in %) of Ecuador per year?
Ensure brevity in your answer.  28.45. What is the average Area (in %) in Samoa per year?
Provide a short and direct response. 20.8. What is the average Area (in %) in Sao Tome and Principe per year?
Offer a terse response. 42.97. What is the average Area (in %) in Turkey per year?
Offer a terse response. 51.7. In the year 1987, what is the difference between the Area (in %) in Ecuador and Area (in %) in Samoa?
Your answer should be very brief. 0.79. In the year 1987, what is the difference between the Area (in %) of Ecuador and Area (in %) of Sao Tome and Principe?
Provide a short and direct response. -11.69. In the year 1987, what is the difference between the Area (in %) of Ecuador and Area (in %) of Turkey?
Your answer should be very brief. -23.34. In the year 1987, what is the difference between the Area (in %) in Samoa and Area (in %) in Sao Tome and Principe?
Provide a short and direct response. -12.48. In the year 1987, what is the difference between the Area (in %) of Samoa and Area (in %) of Turkey?
Give a very brief answer. -24.13. In the year 1987, what is the difference between the Area (in %) in Sao Tome and Principe and Area (in %) in Turkey?
Give a very brief answer. -11.65. In the year 1988, what is the difference between the Area (in %) in Ecuador and Area (in %) in Samoa?
Provide a short and direct response. 0.7. In the year 1988, what is the difference between the Area (in %) in Ecuador and Area (in %) in Sao Tome and Principe?
Ensure brevity in your answer.  -11.68. In the year 1988, what is the difference between the Area (in %) of Ecuador and Area (in %) of Turkey?
Your response must be concise. -23.11. In the year 1988, what is the difference between the Area (in %) of Samoa and Area (in %) of Sao Tome and Principe?
Your answer should be compact. -12.37. In the year 1988, what is the difference between the Area (in %) of Samoa and Area (in %) of Turkey?
Your answer should be compact. -23.81. In the year 1988, what is the difference between the Area (in %) of Sao Tome and Principe and Area (in %) of Turkey?
Give a very brief answer. -11.43. In the year 1989, what is the difference between the Area (in %) in Ecuador and Area (in %) in Samoa?
Give a very brief answer. 8.85. In the year 1989, what is the difference between the Area (in %) of Ecuador and Area (in %) of Sao Tome and Principe?
Make the answer very short. -15.74. In the year 1989, what is the difference between the Area (in %) of Ecuador and Area (in %) of Turkey?
Give a very brief answer. -23.83. In the year 1989, what is the difference between the Area (in %) of Samoa and Area (in %) of Sao Tome and Principe?
Your answer should be very brief. -24.6. In the year 1989, what is the difference between the Area (in %) of Samoa and Area (in %) of Turkey?
Your response must be concise. -32.69. In the year 1989, what is the difference between the Area (in %) of Sao Tome and Principe and Area (in %) of Turkey?
Ensure brevity in your answer.  -8.09. In the year 1990, what is the difference between the Area (in %) of Ecuador and Area (in %) of Samoa?
Provide a short and direct response. 9.26. In the year 1990, what is the difference between the Area (in %) of Ecuador and Area (in %) of Sao Tome and Principe?
Your response must be concise. -15.41. In the year 1990, what is the difference between the Area (in %) in Ecuador and Area (in %) in Turkey?
Your answer should be very brief. -23.21. In the year 1990, what is the difference between the Area (in %) of Samoa and Area (in %) of Sao Tome and Principe?
Ensure brevity in your answer.  -24.67. In the year 1990, what is the difference between the Area (in %) of Samoa and Area (in %) of Turkey?
Your answer should be very brief. -32.47. In the year 1990, what is the difference between the Area (in %) of Sao Tome and Principe and Area (in %) of Turkey?
Make the answer very short. -7.8. In the year 1991, what is the difference between the Area (in %) of Ecuador and Area (in %) of Samoa?
Offer a terse response. 9.51. In the year 1991, what is the difference between the Area (in %) in Ecuador and Area (in %) in Sao Tome and Principe?
Your response must be concise. -15.16. In the year 1991, what is the difference between the Area (in %) in Ecuador and Area (in %) in Turkey?
Keep it short and to the point. -23.47. In the year 1991, what is the difference between the Area (in %) of Samoa and Area (in %) of Sao Tome and Principe?
Your answer should be very brief. -24.67. In the year 1991, what is the difference between the Area (in %) in Samoa and Area (in %) in Turkey?
Ensure brevity in your answer.  -32.98. In the year 1991, what is the difference between the Area (in %) of Sao Tome and Principe and Area (in %) of Turkey?
Your response must be concise. -8.31. In the year 1992, what is the difference between the Area (in %) of Ecuador and Area (in %) of Samoa?
Ensure brevity in your answer.  10.35. In the year 1992, what is the difference between the Area (in %) of Ecuador and Area (in %) of Sao Tome and Principe?
Your answer should be very brief. -15.02. In the year 1992, what is the difference between the Area (in %) in Ecuador and Area (in %) in Turkey?
Make the answer very short. -23.12. In the year 1992, what is the difference between the Area (in %) of Samoa and Area (in %) of Sao Tome and Principe?
Keep it short and to the point. -25.38. In the year 1992, what is the difference between the Area (in %) in Samoa and Area (in %) in Turkey?
Provide a succinct answer. -33.47. In the year 1992, what is the difference between the Area (in %) of Sao Tome and Principe and Area (in %) of Turkey?
Make the answer very short. -8.1. In the year 1993, what is the difference between the Area (in %) of Ecuador and Area (in %) of Samoa?
Your answer should be compact. 10.43. In the year 1993, what is the difference between the Area (in %) in Ecuador and Area (in %) in Sao Tome and Principe?
Your answer should be compact. -14.94. In the year 1993, what is the difference between the Area (in %) in Ecuador and Area (in %) in Turkey?
Make the answer very short. -23.05. In the year 1993, what is the difference between the Area (in %) in Samoa and Area (in %) in Sao Tome and Principe?
Your response must be concise. -25.38. In the year 1993, what is the difference between the Area (in %) in Samoa and Area (in %) in Turkey?
Ensure brevity in your answer.  -33.49. In the year 1993, what is the difference between the Area (in %) in Sao Tome and Principe and Area (in %) in Turkey?
Offer a terse response. -8.11. In the year 1994, what is the difference between the Area (in %) of Ecuador and Area (in %) of Samoa?
Offer a very short reply. 11.34. In the year 1994, what is the difference between the Area (in %) of Ecuador and Area (in %) of Sao Tome and Principe?
Provide a short and direct response. -16.47. In the year 1994, what is the difference between the Area (in %) of Ecuador and Area (in %) of Turkey?
Offer a very short reply. -22.8. In the year 1994, what is the difference between the Area (in %) of Samoa and Area (in %) of Sao Tome and Principe?
Your response must be concise. -27.81. In the year 1994, what is the difference between the Area (in %) of Samoa and Area (in %) of Turkey?
Provide a short and direct response. -34.15. In the year 1994, what is the difference between the Area (in %) in Sao Tome and Principe and Area (in %) in Turkey?
Ensure brevity in your answer.  -6.33. What is the ratio of the Area (in %) in Ecuador in 1987 to that in 1988?
Provide a short and direct response. 1. What is the ratio of the Area (in %) in Sao Tome and Principe in 1987 to that in 1988?
Keep it short and to the point. 1. What is the ratio of the Area (in %) of Turkey in 1987 to that in 1988?
Your answer should be very brief. 1. What is the ratio of the Area (in %) in Samoa in 1987 to that in 1989?
Offer a terse response. 1.42. What is the ratio of the Area (in %) of Sao Tome and Principe in 1987 to that in 1989?
Provide a succinct answer. 0.9. What is the ratio of the Area (in %) of Turkey in 1987 to that in 1989?
Offer a terse response. 0.99. What is the ratio of the Area (in %) of Ecuador in 1987 to that in 1990?
Keep it short and to the point. 0.98. What is the ratio of the Area (in %) in Samoa in 1987 to that in 1990?
Offer a very short reply. 1.42. What is the ratio of the Area (in %) of Sao Tome and Principe in 1987 to that in 1990?
Make the answer very short. 0.9. What is the ratio of the Area (in %) of Turkey in 1987 to that in 1990?
Offer a very short reply. 0.99. What is the ratio of the Area (in %) in Ecuador in 1987 to that in 1991?
Offer a very short reply. 0.98. What is the ratio of the Area (in %) in Samoa in 1987 to that in 1991?
Your response must be concise. 1.42. What is the ratio of the Area (in %) in Sao Tome and Principe in 1987 to that in 1991?
Make the answer very short. 0.9. What is the ratio of the Area (in %) of Turkey in 1987 to that in 1991?
Offer a very short reply. 0.98. What is the ratio of the Area (in %) in Ecuador in 1987 to that in 1992?
Your answer should be very brief. 0.97. What is the ratio of the Area (in %) of Samoa in 1987 to that in 1992?
Ensure brevity in your answer.  1.48. What is the ratio of the Area (in %) in Sao Tome and Principe in 1987 to that in 1992?
Keep it short and to the point. 0.9. What is the ratio of the Area (in %) in Turkey in 1987 to that in 1992?
Offer a terse response. 0.99. What is the ratio of the Area (in %) of Ecuador in 1987 to that in 1993?
Offer a terse response. 0.97. What is the ratio of the Area (in %) of Samoa in 1987 to that in 1993?
Your answer should be very brief. 1.48. What is the ratio of the Area (in %) of Sao Tome and Principe in 1987 to that in 1993?
Give a very brief answer. 0.9. What is the ratio of the Area (in %) of Ecuador in 1987 to that in 1994?
Keep it short and to the point. 0.95. What is the ratio of the Area (in %) of Samoa in 1987 to that in 1994?
Make the answer very short. 1.5. What is the ratio of the Area (in %) of Sao Tome and Principe in 1987 to that in 1994?
Ensure brevity in your answer.  0.86. What is the ratio of the Area (in %) of Turkey in 1987 to that in 1994?
Your response must be concise. 0.98. What is the ratio of the Area (in %) of Ecuador in 1988 to that in 1989?
Your answer should be very brief. 1. What is the ratio of the Area (in %) in Samoa in 1988 to that in 1989?
Your answer should be very brief. 1.42. What is the ratio of the Area (in %) of Sao Tome and Principe in 1988 to that in 1989?
Your response must be concise. 0.9. What is the ratio of the Area (in %) in Turkey in 1988 to that in 1989?
Your response must be concise. 0.98. What is the ratio of the Area (in %) in Ecuador in 1988 to that in 1990?
Give a very brief answer. 0.98. What is the ratio of the Area (in %) in Samoa in 1988 to that in 1990?
Make the answer very short. 1.43. What is the ratio of the Area (in %) of Sao Tome and Principe in 1988 to that in 1990?
Give a very brief answer. 0.9. What is the ratio of the Area (in %) in Ecuador in 1988 to that in 1991?
Your answer should be very brief. 0.98. What is the ratio of the Area (in %) of Samoa in 1988 to that in 1991?
Give a very brief answer. 1.43. What is the ratio of the Area (in %) in Sao Tome and Principe in 1988 to that in 1991?
Make the answer very short. 0.9. What is the ratio of the Area (in %) in Turkey in 1988 to that in 1991?
Provide a short and direct response. 0.98. What is the ratio of the Area (in %) of Ecuador in 1988 to that in 1992?
Provide a succinct answer. 0.97. What is the ratio of the Area (in %) in Samoa in 1988 to that in 1992?
Your answer should be very brief. 1.48. What is the ratio of the Area (in %) of Sao Tome and Principe in 1988 to that in 1992?
Offer a very short reply. 0.9. What is the ratio of the Area (in %) in Turkey in 1988 to that in 1992?
Provide a short and direct response. 0.98. What is the ratio of the Area (in %) of Ecuador in 1988 to that in 1993?
Provide a succinct answer. 0.97. What is the ratio of the Area (in %) of Samoa in 1988 to that in 1993?
Ensure brevity in your answer.  1.48. What is the ratio of the Area (in %) of Sao Tome and Principe in 1988 to that in 1993?
Your response must be concise. 0.9. What is the ratio of the Area (in %) in Turkey in 1988 to that in 1993?
Offer a very short reply. 0.98. What is the ratio of the Area (in %) of Ecuador in 1988 to that in 1994?
Ensure brevity in your answer.  0.95. What is the ratio of the Area (in %) of Samoa in 1988 to that in 1994?
Your response must be concise. 1.51. What is the ratio of the Area (in %) of Sao Tome and Principe in 1988 to that in 1994?
Offer a terse response. 0.86. What is the ratio of the Area (in %) of Turkey in 1988 to that in 1994?
Your response must be concise. 0.98. What is the ratio of the Area (in %) in Samoa in 1989 to that in 1990?
Your answer should be compact. 1. What is the ratio of the Area (in %) of Turkey in 1989 to that in 1990?
Your answer should be very brief. 1.01. What is the ratio of the Area (in %) in Ecuador in 1989 to that in 1991?
Ensure brevity in your answer.  0.98. What is the ratio of the Area (in %) in Samoa in 1989 to that in 1991?
Make the answer very short. 1. What is the ratio of the Area (in %) in Ecuador in 1989 to that in 1992?
Make the answer very short. 0.97. What is the ratio of the Area (in %) of Samoa in 1989 to that in 1992?
Your answer should be very brief. 1.04. What is the ratio of the Area (in %) of Sao Tome and Principe in 1989 to that in 1992?
Provide a short and direct response. 1. What is the ratio of the Area (in %) of Turkey in 1989 to that in 1992?
Your answer should be compact. 1. What is the ratio of the Area (in %) of Ecuador in 1989 to that in 1993?
Offer a terse response. 0.97. What is the ratio of the Area (in %) in Samoa in 1989 to that in 1993?
Give a very brief answer. 1.04. What is the ratio of the Area (in %) of Turkey in 1989 to that in 1993?
Offer a very short reply. 1. What is the ratio of the Area (in %) in Ecuador in 1989 to that in 1994?
Give a very brief answer. 0.95. What is the ratio of the Area (in %) in Samoa in 1989 to that in 1994?
Keep it short and to the point. 1.06. What is the ratio of the Area (in %) in Sao Tome and Principe in 1989 to that in 1994?
Provide a succinct answer. 0.95. What is the ratio of the Area (in %) in Turkey in 1989 to that in 1994?
Ensure brevity in your answer.  0.99. What is the ratio of the Area (in %) in Ecuador in 1990 to that in 1991?
Your answer should be compact. 0.99. What is the ratio of the Area (in %) of Samoa in 1990 to that in 1991?
Your response must be concise. 1. What is the ratio of the Area (in %) in Sao Tome and Principe in 1990 to that in 1991?
Your answer should be compact. 1. What is the ratio of the Area (in %) of Turkey in 1990 to that in 1991?
Your answer should be compact. 0.99. What is the ratio of the Area (in %) in Ecuador in 1990 to that in 1992?
Your answer should be very brief. 0.99. What is the ratio of the Area (in %) of Turkey in 1990 to that in 1992?
Offer a very short reply. 0.99. What is the ratio of the Area (in %) of Ecuador in 1990 to that in 1993?
Offer a terse response. 0.98. What is the ratio of the Area (in %) in Sao Tome and Principe in 1990 to that in 1993?
Make the answer very short. 1. What is the ratio of the Area (in %) of Turkey in 1990 to that in 1993?
Keep it short and to the point. 0.99. What is the ratio of the Area (in %) in Ecuador in 1990 to that in 1994?
Give a very brief answer. 0.97. What is the ratio of the Area (in %) of Samoa in 1990 to that in 1994?
Your answer should be very brief. 1.06. What is the ratio of the Area (in %) in Sao Tome and Principe in 1990 to that in 1994?
Make the answer very short. 0.95. What is the ratio of the Area (in %) in Turkey in 1990 to that in 1994?
Your answer should be compact. 0.99. What is the ratio of the Area (in %) in Ecuador in 1991 to that in 1992?
Your answer should be very brief. 1. What is the ratio of the Area (in %) of Turkey in 1991 to that in 1992?
Make the answer very short. 1. What is the ratio of the Area (in %) of Ecuador in 1991 to that in 1993?
Offer a terse response. 0.99. What is the ratio of the Area (in %) of Sao Tome and Principe in 1991 to that in 1993?
Keep it short and to the point. 1. What is the ratio of the Area (in %) in Turkey in 1991 to that in 1993?
Provide a short and direct response. 1. What is the ratio of the Area (in %) of Ecuador in 1991 to that in 1994?
Make the answer very short. 0.97. What is the ratio of the Area (in %) of Samoa in 1991 to that in 1994?
Make the answer very short. 1.06. What is the ratio of the Area (in %) of Sao Tome and Principe in 1991 to that in 1994?
Your answer should be very brief. 0.95. What is the ratio of the Area (in %) of Turkey in 1991 to that in 1994?
Offer a terse response. 1. What is the ratio of the Area (in %) of Ecuador in 1992 to that in 1993?
Offer a very short reply. 1. What is the ratio of the Area (in %) in Samoa in 1992 to that in 1993?
Ensure brevity in your answer.  1. What is the ratio of the Area (in %) of Turkey in 1992 to that in 1993?
Make the answer very short. 1. What is the ratio of the Area (in %) of Ecuador in 1992 to that in 1994?
Make the answer very short. 0.98. What is the ratio of the Area (in %) in Samoa in 1992 to that in 1994?
Your response must be concise. 1.02. What is the ratio of the Area (in %) in Sao Tome and Principe in 1992 to that in 1994?
Ensure brevity in your answer.  0.95. What is the ratio of the Area (in %) in Ecuador in 1993 to that in 1994?
Give a very brief answer. 0.98. What is the ratio of the Area (in %) in Samoa in 1993 to that in 1994?
Your answer should be compact. 1.02. What is the ratio of the Area (in %) in Sao Tome and Principe in 1993 to that in 1994?
Provide a short and direct response. 0.95. What is the difference between the highest and the second highest Area (in %) in Ecuador?
Ensure brevity in your answer.  0.56. What is the difference between the highest and the second highest Area (in %) of Samoa?
Provide a succinct answer. 0.11. What is the difference between the highest and the second highest Area (in %) in Sao Tome and Principe?
Offer a very short reply. 2.08. What is the difference between the highest and the second highest Area (in %) in Turkey?
Make the answer very short. 0.11. What is the difference between the highest and the lowest Area (in %) of Ecuador?
Provide a short and direct response. 1.47. What is the difference between the highest and the lowest Area (in %) of Samoa?
Provide a succinct answer. 9.19. What is the difference between the highest and the lowest Area (in %) in Sao Tome and Principe?
Keep it short and to the point. 6.25. What is the difference between the highest and the lowest Area (in %) in Turkey?
Your answer should be very brief. 1.15. 